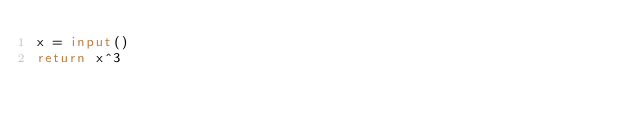<code> <loc_0><loc_0><loc_500><loc_500><_Python_>x = input()
return x^3</code> 